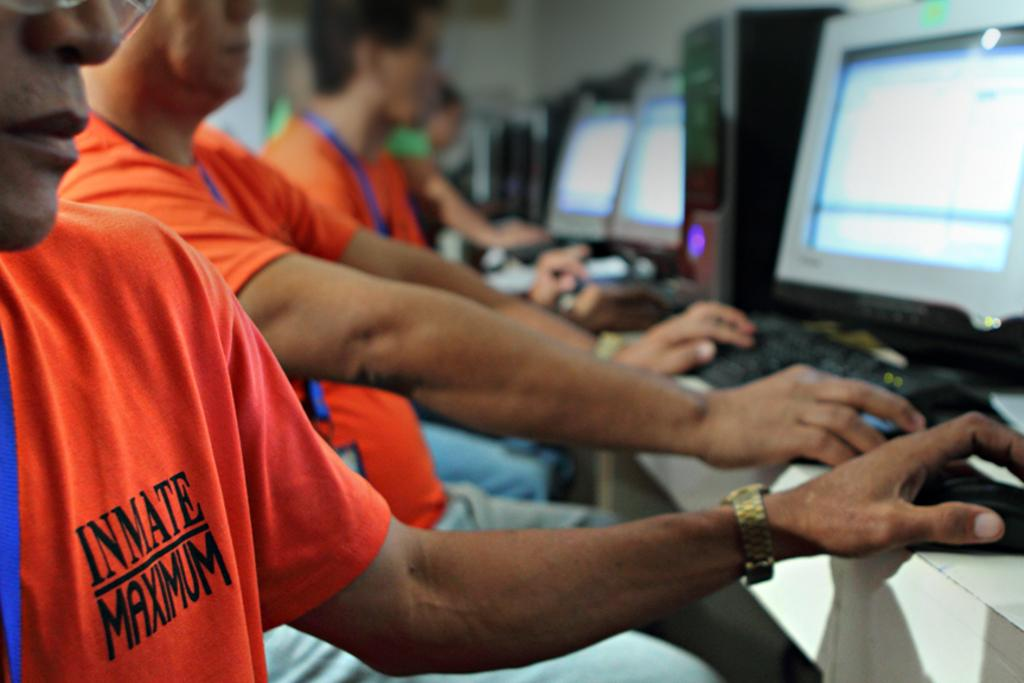<image>
Describe the image concisely. A bunch of inmates at a maximum security prison are using computers. 